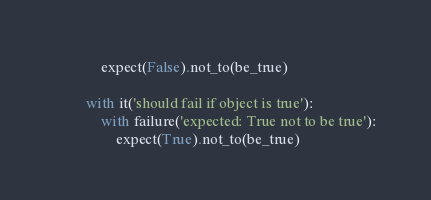Convert code to text. <code><loc_0><loc_0><loc_500><loc_500><_Python_>            expect(False).not_to(be_true)

        with it('should fail if object is true'):
            with failure('expected: True not to be true'):
                expect(True).not_to(be_true)
</code> 